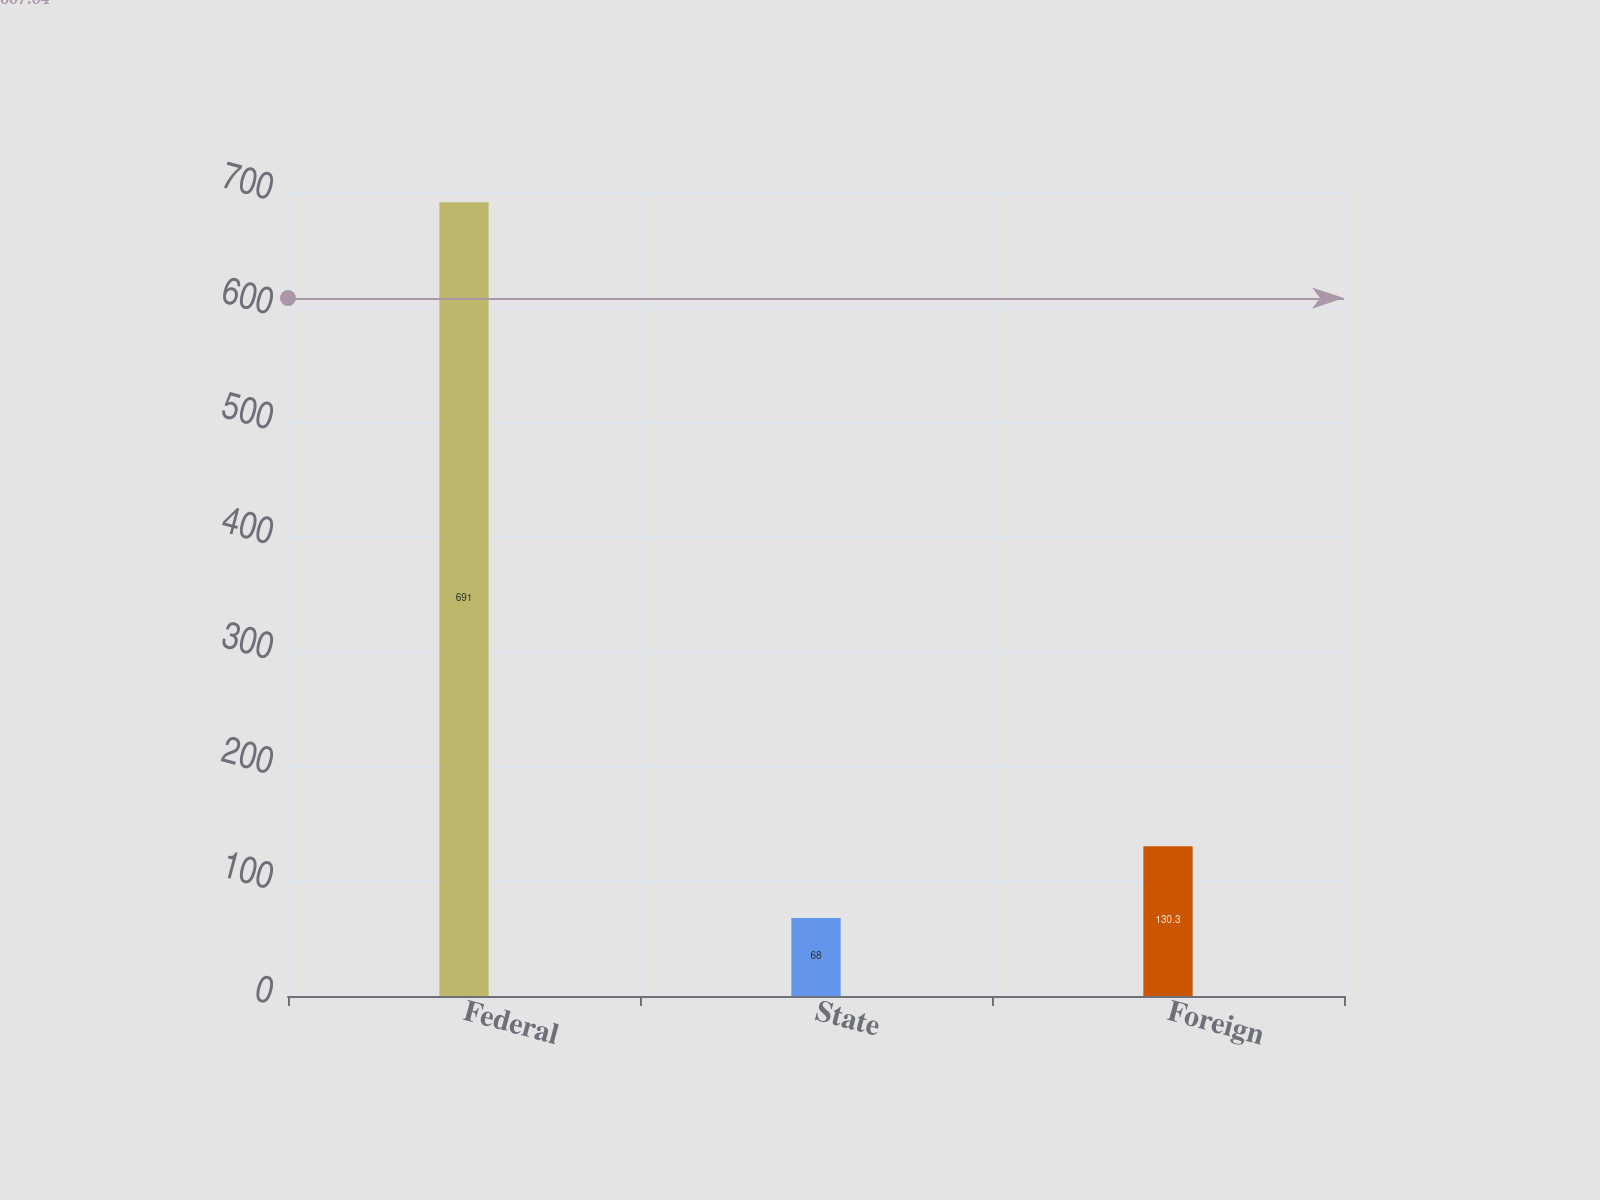<chart> <loc_0><loc_0><loc_500><loc_500><bar_chart><fcel>Federal<fcel>State<fcel>Foreign<nl><fcel>691<fcel>68<fcel>130.3<nl></chart> 